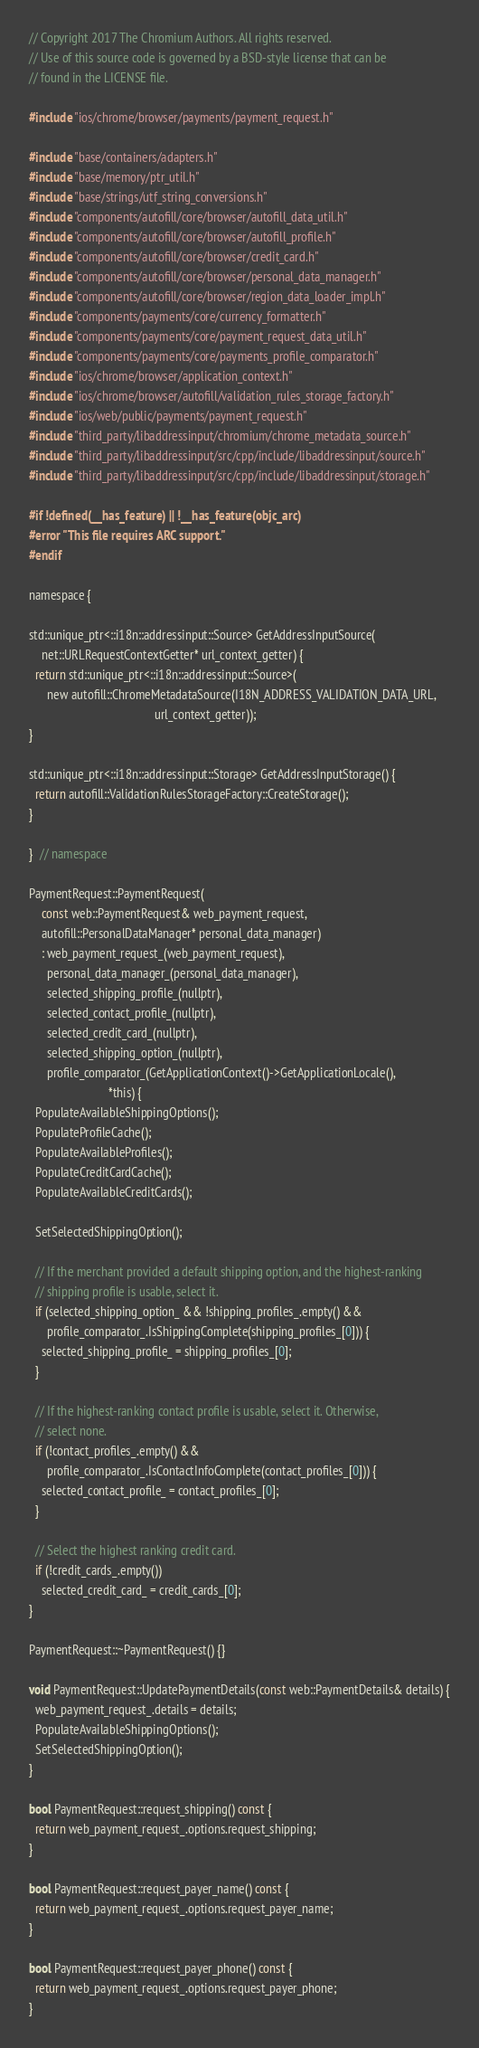Convert code to text. <code><loc_0><loc_0><loc_500><loc_500><_ObjectiveC_>// Copyright 2017 The Chromium Authors. All rights reserved.
// Use of this source code is governed by a BSD-style license that can be
// found in the LICENSE file.

#include "ios/chrome/browser/payments/payment_request.h"

#include "base/containers/adapters.h"
#include "base/memory/ptr_util.h"
#include "base/strings/utf_string_conversions.h"
#include "components/autofill/core/browser/autofill_data_util.h"
#include "components/autofill/core/browser/autofill_profile.h"
#include "components/autofill/core/browser/credit_card.h"
#include "components/autofill/core/browser/personal_data_manager.h"
#include "components/autofill/core/browser/region_data_loader_impl.h"
#include "components/payments/core/currency_formatter.h"
#include "components/payments/core/payment_request_data_util.h"
#include "components/payments/core/payments_profile_comparator.h"
#include "ios/chrome/browser/application_context.h"
#include "ios/chrome/browser/autofill/validation_rules_storage_factory.h"
#include "ios/web/public/payments/payment_request.h"
#include "third_party/libaddressinput/chromium/chrome_metadata_source.h"
#include "third_party/libaddressinput/src/cpp/include/libaddressinput/source.h"
#include "third_party/libaddressinput/src/cpp/include/libaddressinput/storage.h"

#if !defined(__has_feature) || !__has_feature(objc_arc)
#error "This file requires ARC support."
#endif

namespace {

std::unique_ptr<::i18n::addressinput::Source> GetAddressInputSource(
    net::URLRequestContextGetter* url_context_getter) {
  return std::unique_ptr<::i18n::addressinput::Source>(
      new autofill::ChromeMetadataSource(I18N_ADDRESS_VALIDATION_DATA_URL,
                                         url_context_getter));
}

std::unique_ptr<::i18n::addressinput::Storage> GetAddressInputStorage() {
  return autofill::ValidationRulesStorageFactory::CreateStorage();
}

}  // namespace

PaymentRequest::PaymentRequest(
    const web::PaymentRequest& web_payment_request,
    autofill::PersonalDataManager* personal_data_manager)
    : web_payment_request_(web_payment_request),
      personal_data_manager_(personal_data_manager),
      selected_shipping_profile_(nullptr),
      selected_contact_profile_(nullptr),
      selected_credit_card_(nullptr),
      selected_shipping_option_(nullptr),
      profile_comparator_(GetApplicationContext()->GetApplicationLocale(),
                          *this) {
  PopulateAvailableShippingOptions();
  PopulateProfileCache();
  PopulateAvailableProfiles();
  PopulateCreditCardCache();
  PopulateAvailableCreditCards();

  SetSelectedShippingOption();

  // If the merchant provided a default shipping option, and the highest-ranking
  // shipping profile is usable, select it.
  if (selected_shipping_option_ && !shipping_profiles_.empty() &&
      profile_comparator_.IsShippingComplete(shipping_profiles_[0])) {
    selected_shipping_profile_ = shipping_profiles_[0];
  }

  // If the highest-ranking contact profile is usable, select it. Otherwise,
  // select none.
  if (!contact_profiles_.empty() &&
      profile_comparator_.IsContactInfoComplete(contact_profiles_[0])) {
    selected_contact_profile_ = contact_profiles_[0];
  }

  // Select the highest ranking credit card.
  if (!credit_cards_.empty())
    selected_credit_card_ = credit_cards_[0];
}

PaymentRequest::~PaymentRequest() {}

void PaymentRequest::UpdatePaymentDetails(const web::PaymentDetails& details) {
  web_payment_request_.details = details;
  PopulateAvailableShippingOptions();
  SetSelectedShippingOption();
}

bool PaymentRequest::request_shipping() const {
  return web_payment_request_.options.request_shipping;
}

bool PaymentRequest::request_payer_name() const {
  return web_payment_request_.options.request_payer_name;
}

bool PaymentRequest::request_payer_phone() const {
  return web_payment_request_.options.request_payer_phone;
}
</code> 